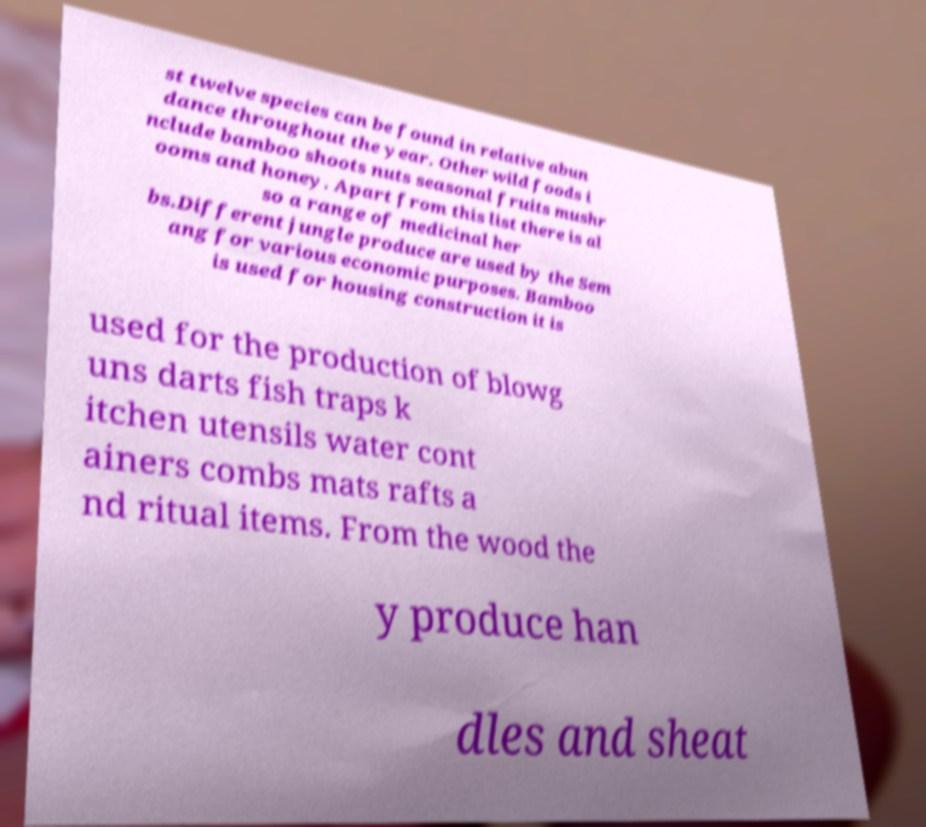Please read and relay the text visible in this image. What does it say? st twelve species can be found in relative abun dance throughout the year. Other wild foods i nclude bamboo shoots nuts seasonal fruits mushr ooms and honey. Apart from this list there is al so a range of medicinal her bs.Different jungle produce are used by the Sem ang for various economic purposes. Bamboo is used for housing construction it is used for the production of blowg uns darts fish traps k itchen utensils water cont ainers combs mats rafts a nd ritual items. From the wood the y produce han dles and sheat 